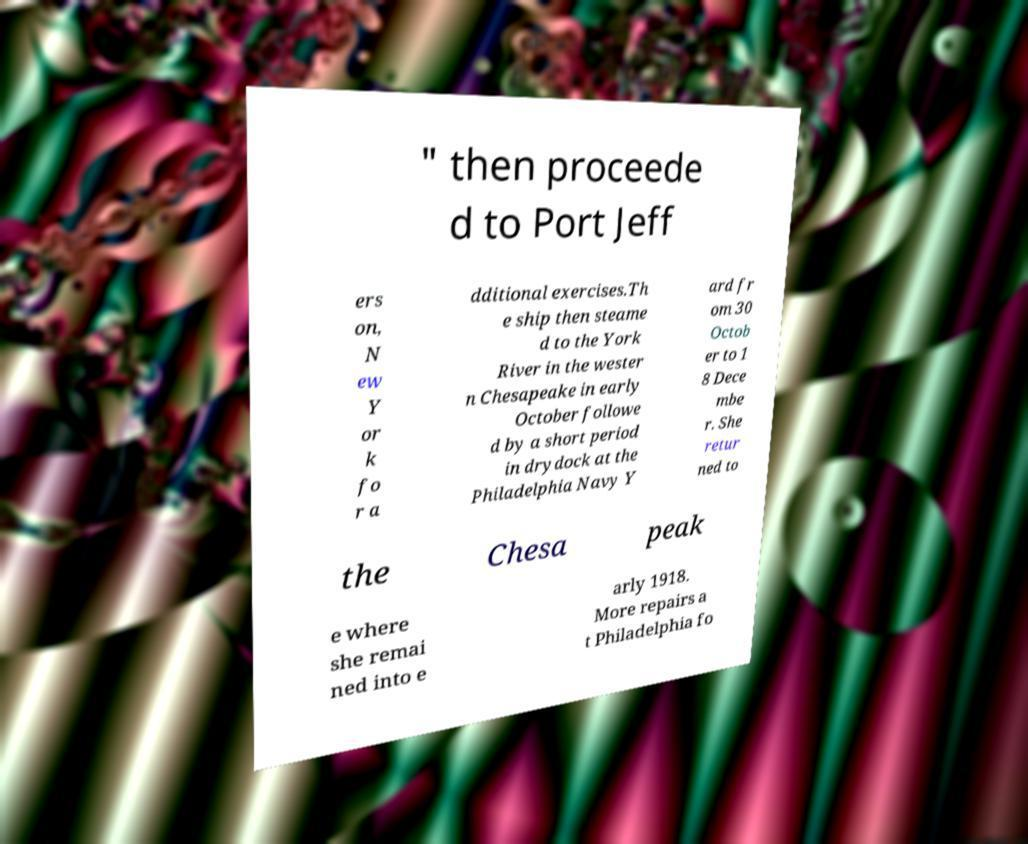Could you extract and type out the text from this image? " then proceede d to Port Jeff ers on, N ew Y or k fo r a dditional exercises.Th e ship then steame d to the York River in the wester n Chesapeake in early October followe d by a short period in drydock at the Philadelphia Navy Y ard fr om 30 Octob er to 1 8 Dece mbe r. She retur ned to the Chesa peak e where she remai ned into e arly 1918. More repairs a t Philadelphia fo 